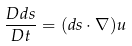Convert formula to latex. <formula><loc_0><loc_0><loc_500><loc_500>\frac { D d s } { D t } = ( d s \cdot \nabla ) u</formula> 